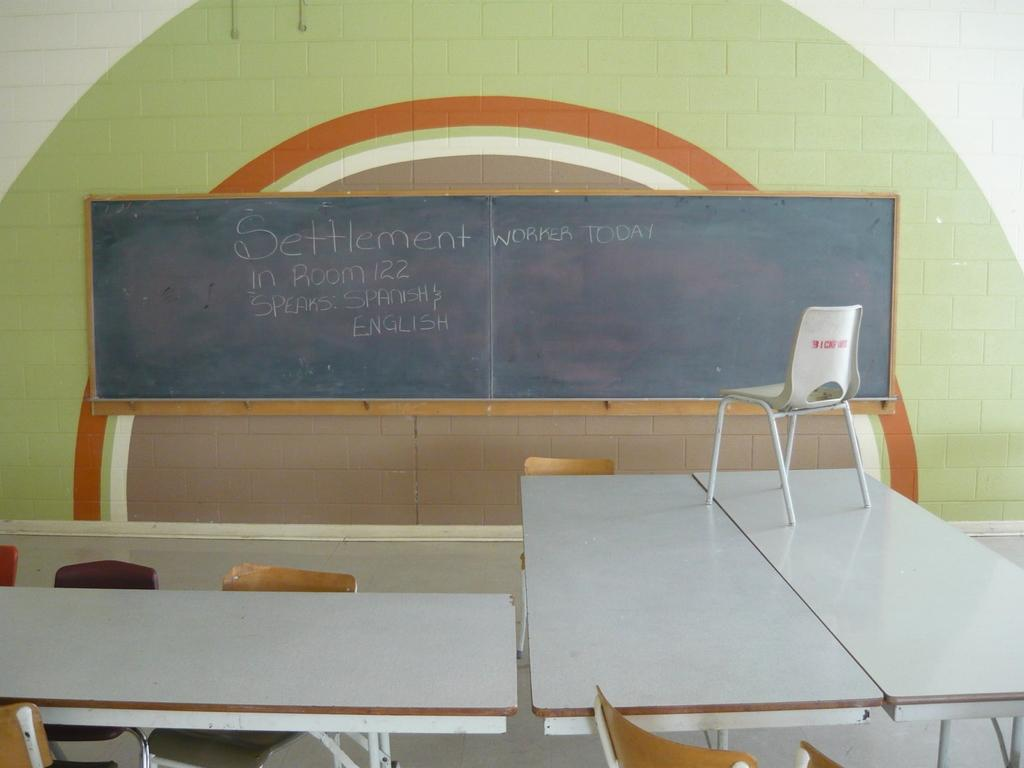<image>
Render a clear and concise summary of the photo. Blackboard inside a store that says the word "Settlement" on it. 